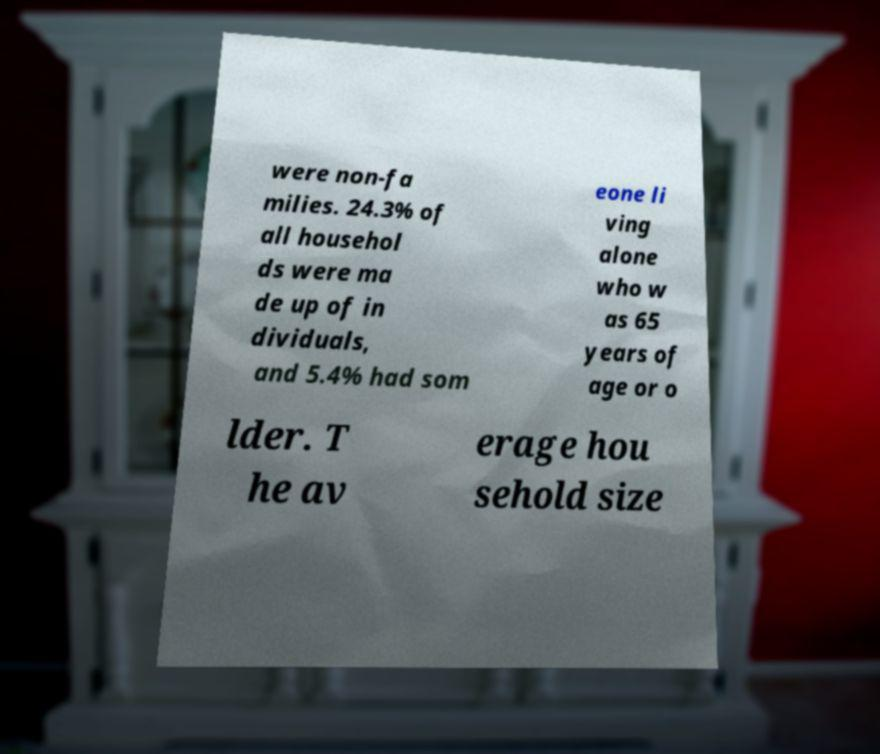Please identify and transcribe the text found in this image. were non-fa milies. 24.3% of all househol ds were ma de up of in dividuals, and 5.4% had som eone li ving alone who w as 65 years of age or o lder. T he av erage hou sehold size 